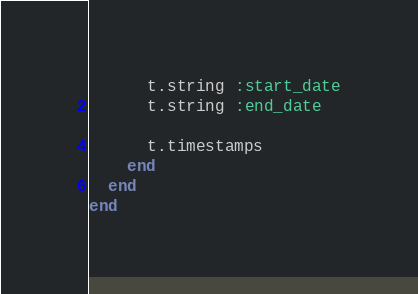Convert code to text. <code><loc_0><loc_0><loc_500><loc_500><_Ruby_>      t.string :start_date
      t.string :end_date

      t.timestamps
    end
  end
end
</code> 